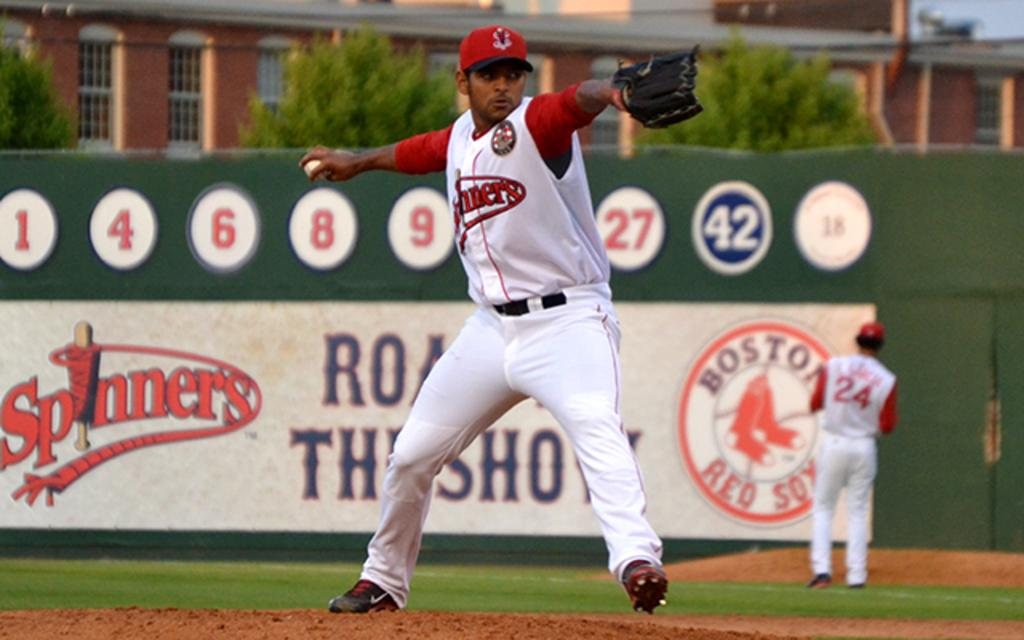Provide a one-sentence caption for the provided image. Boston spinners baseball team is out playing baseball. 